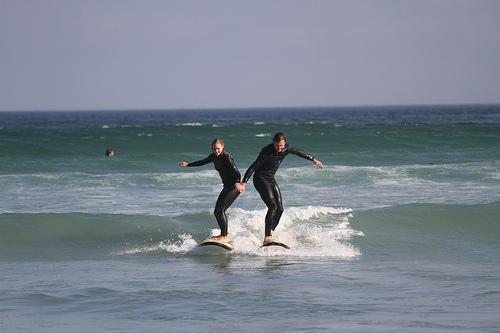How many surfboards are there?
Give a very brief answer. 2. How many people are in the picture?
Give a very brief answer. 3. 